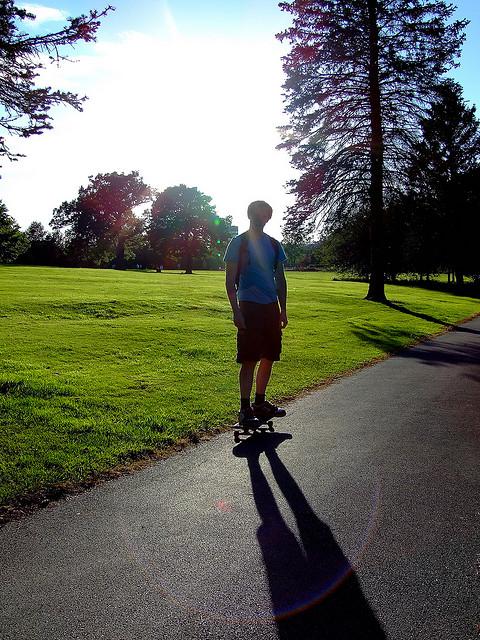Is this a rural area?
Give a very brief answer. Yes. Is it sunny?
Answer briefly. Yes. Is the grass dry?
Write a very short answer. Yes. Does the grass look healthy?
Concise answer only. Yes. What is the young man standing on in the picture?
Answer briefly. Skateboard. 